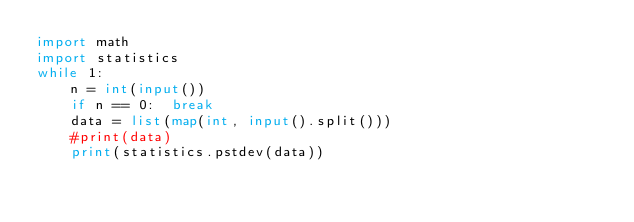<code> <loc_0><loc_0><loc_500><loc_500><_Python_>import math
import statistics
while 1:
    n = int(input())
    if n == 0:  break
    data = list(map(int, input().split()))
    #print(data)
    print(statistics.pstdev(data))
</code> 